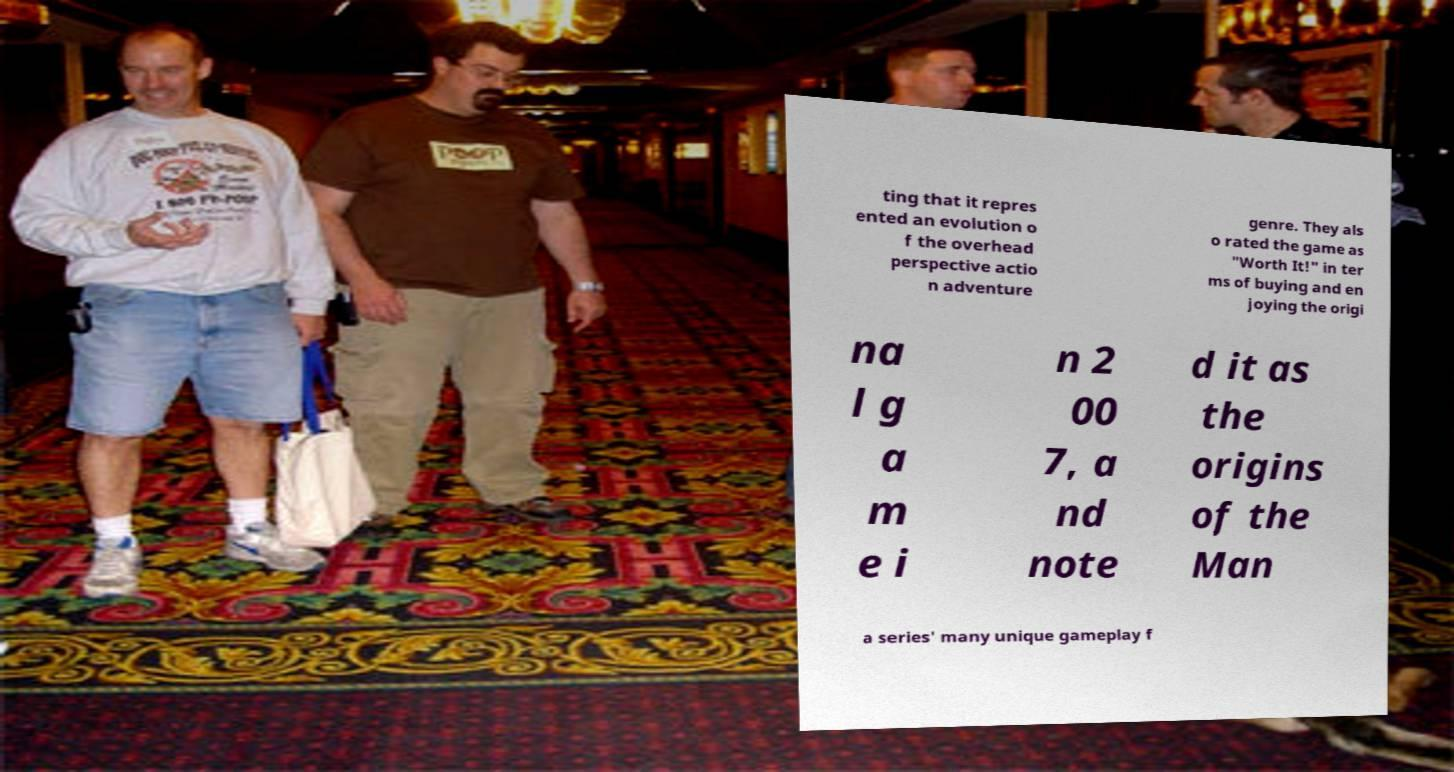Please read and relay the text visible in this image. What does it say? ting that it repres ented an evolution o f the overhead perspective actio n adventure genre. They als o rated the game as "Worth It!" in ter ms of buying and en joying the origi na l g a m e i n 2 00 7, a nd note d it as the origins of the Man a series' many unique gameplay f 